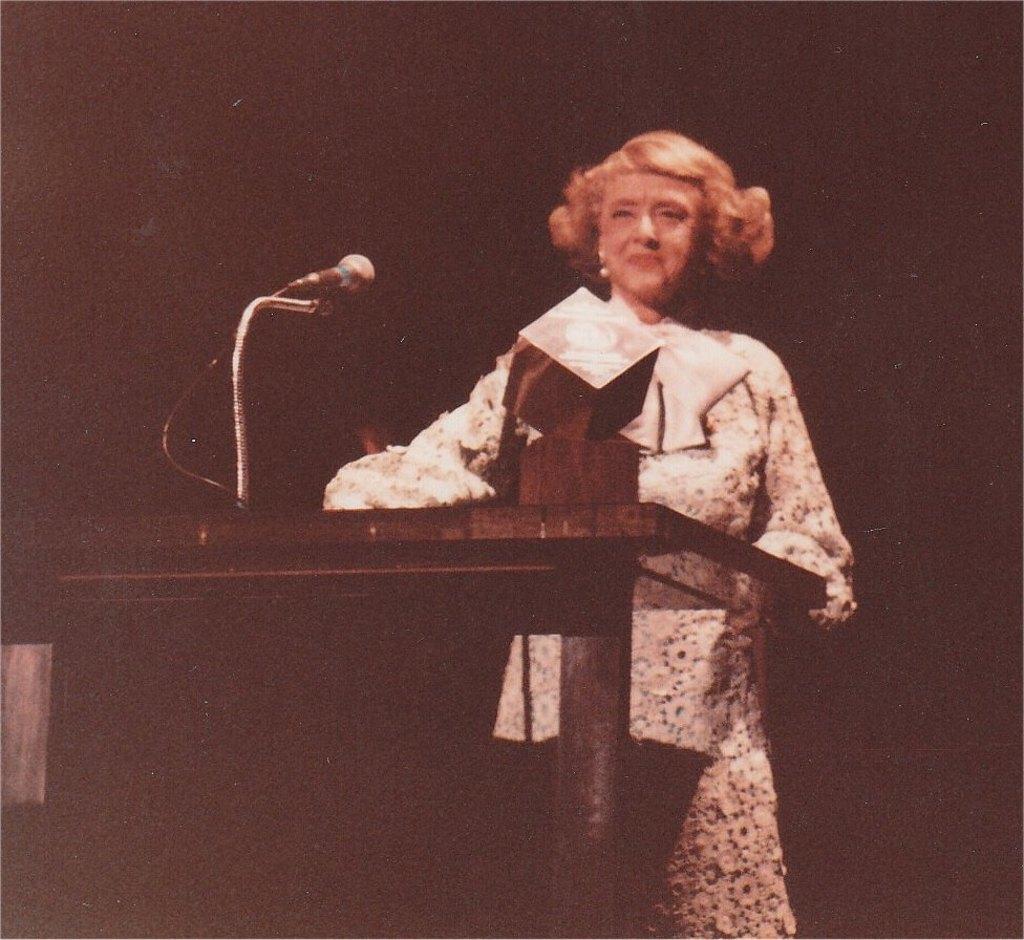Could you give a brief overview of what you see in this image? It looks like an old picture. We can see a woman is standing behind the podium and on the podium there is a microphone with stand, cable and an object. Behind the woman there is a dark background 